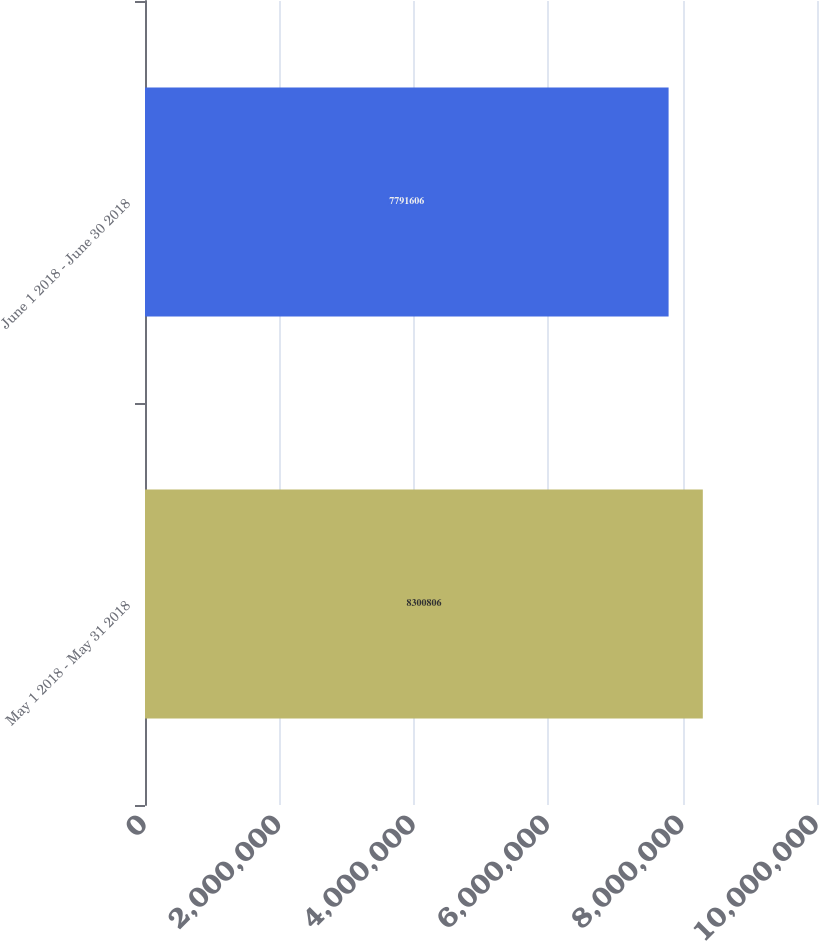Convert chart. <chart><loc_0><loc_0><loc_500><loc_500><bar_chart><fcel>May 1 2018 - May 31 2018<fcel>June 1 2018 - June 30 2018<nl><fcel>8.30081e+06<fcel>7.79161e+06<nl></chart> 